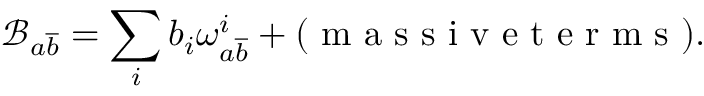Convert formula to latex. <formula><loc_0><loc_0><loc_500><loc_500>\mathcal { B } _ { a \overline { b } } = \sum _ { i } b _ { i } \omega _ { a \overline { b } } ^ { i } + ( m a s s i v e t e r m s ) .</formula> 